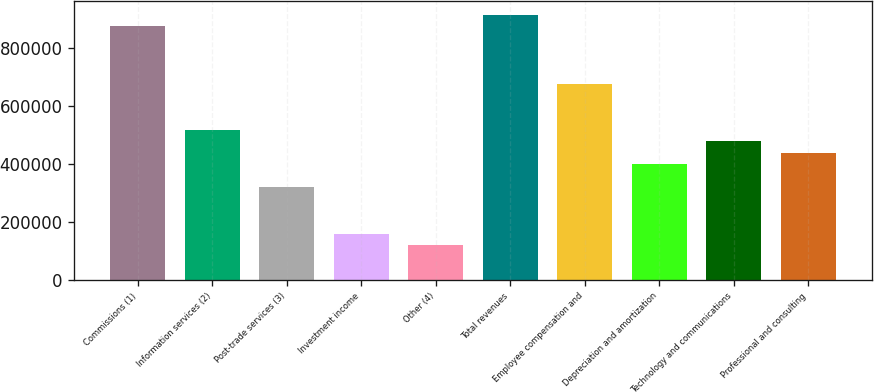Convert chart. <chart><loc_0><loc_0><loc_500><loc_500><bar_chart><fcel>Commissions (1)<fcel>Information services (2)<fcel>Post-trade services (3)<fcel>Investment income<fcel>Other (4)<fcel>Total revenues<fcel>Employee compensation and<fcel>Depreciation and amortization<fcel>Technology and communications<fcel>Professional and consulting<nl><fcel>874435<fcel>516712<fcel>317977<fcel>158989<fcel>119242<fcel>914182<fcel>675700<fcel>397471<fcel>476965<fcel>437218<nl></chart> 